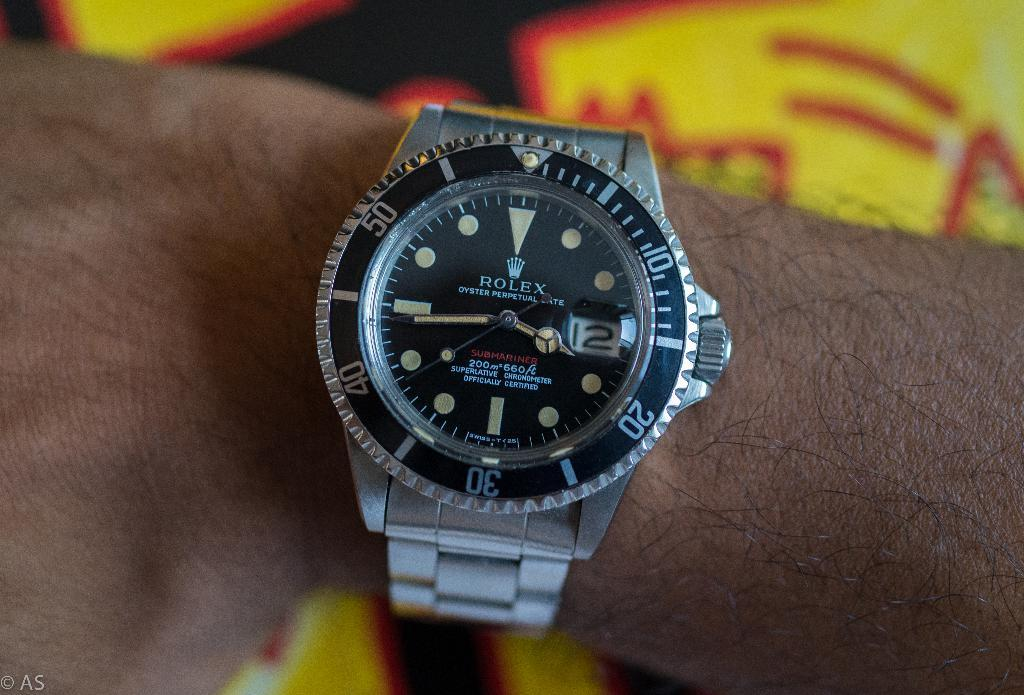Provide a one-sentence caption for the provided image. A silver Rolex Submariner displays the time 3:44. 